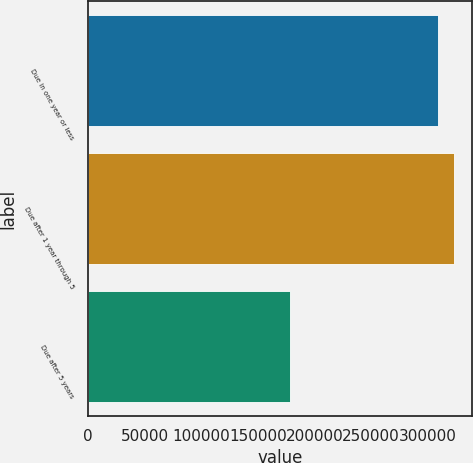Convert chart. <chart><loc_0><loc_0><loc_500><loc_500><bar_chart><fcel>Due in one year or less<fcel>Due after 1 year through 5<fcel>Due after 5 years<nl><fcel>309236<fcel>323126<fcel>177919<nl></chart> 